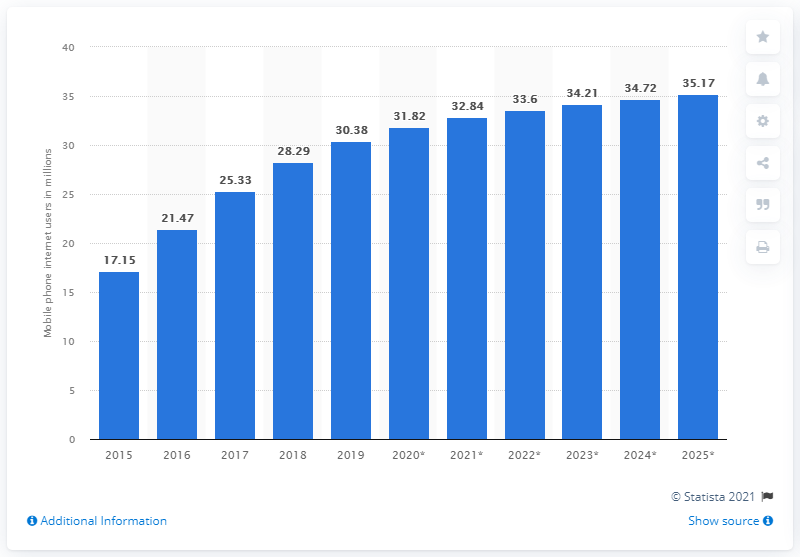Identify some key points in this picture. In 2015, there were 17.15 million mobile phone users in Argentina. By the end of 2020, it is projected that 31.82% of Argentine mobile phone users will access the internet from their devices. 